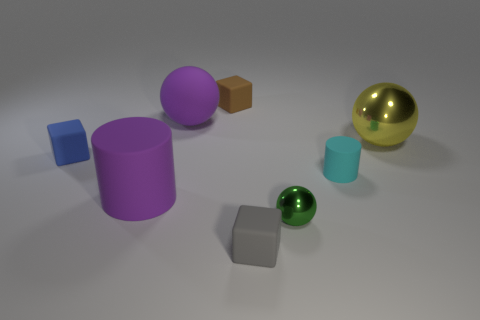Can you describe the arrangement and different colors of the objects in this image? Certainly! In the foreground, there is a small blue cube on the left and a small teal cylinder to its right. Behind these, you'll find a large purple cylinder and further back a gray cube. On the far right, there is a large green sphere in the middle ground, and just beyond it, a gold sphere shines prominently. 